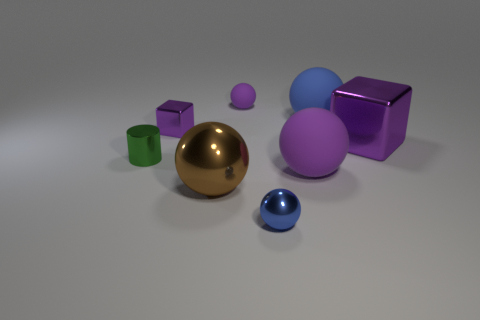Subtract all brown spheres. How many spheres are left? 4 Subtract all small blue shiny balls. How many balls are left? 4 Subtract all red spheres. Subtract all purple cylinders. How many spheres are left? 5 Add 1 small green metal cubes. How many objects exist? 9 Subtract all cylinders. How many objects are left? 7 Subtract 0 red cylinders. How many objects are left? 8 Subtract all blue objects. Subtract all red matte cubes. How many objects are left? 6 Add 2 shiny cubes. How many shiny cubes are left? 4 Add 2 big gray matte cylinders. How many big gray matte cylinders exist? 2 